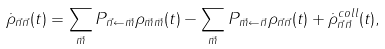Convert formula to latex. <formula><loc_0><loc_0><loc_500><loc_500>\dot { \rho } _ { \vec { n } \vec { n } } ( t ) = \sum _ { \vec { m } } P _ { \vec { n } \leftarrow \vec { m } } \rho _ { \vec { m } \vec { m } } ( t ) - \sum _ { \vec { m } } P _ { \vec { m } \leftarrow \vec { n } } \rho _ { \vec { n } \vec { n } } ( t ) + \dot { \rho } ^ { c o l l } _ { \vec { n } \vec { n } } ( t ) ,</formula> 